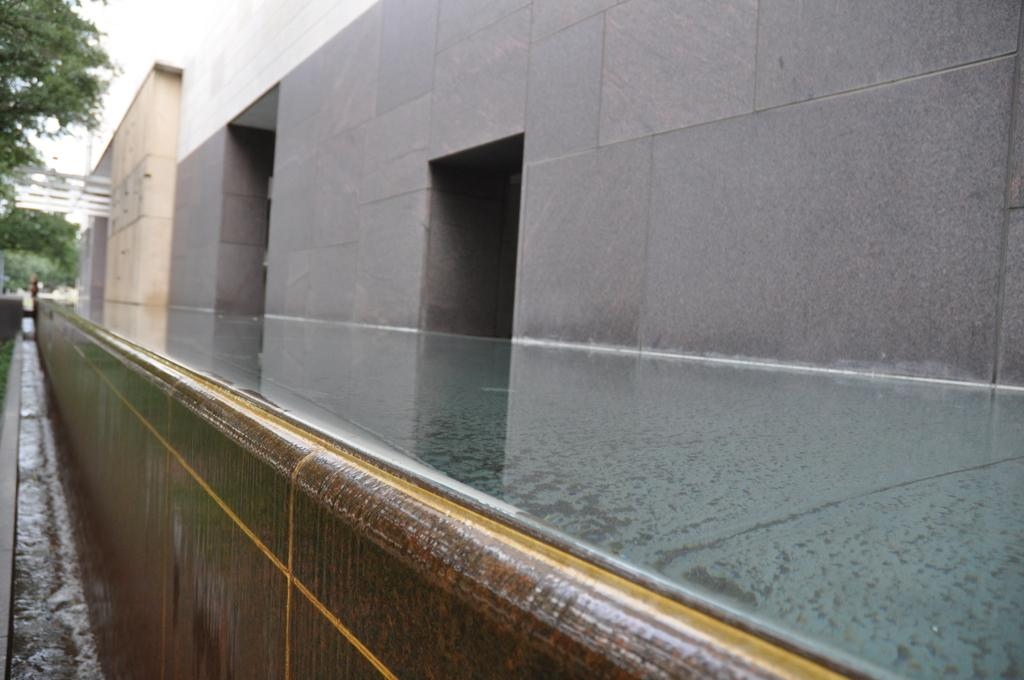What is in the foreground of the image? There is a pavement in the foreground of the image. What is located near the pavement? The pavement is beside a building. What can be seen on the left side of the image? There are trees on the left side of the image. What is the purpose of the space on the left side of the image? There is a drain space on the left side of the image. What type of apple is being used as a decoration on the building in the image? There is no apple present in the image; it features a pavement, a building, trees, and a drain space. 